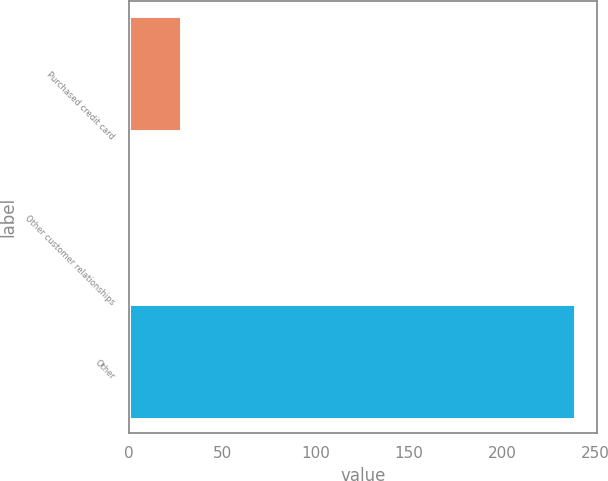Convert chart. <chart><loc_0><loc_0><loc_500><loc_500><bar_chart><fcel>Purchased credit card<fcel>Other customer relationships<fcel>Other<nl><fcel>28<fcel>1<fcel>239<nl></chart> 